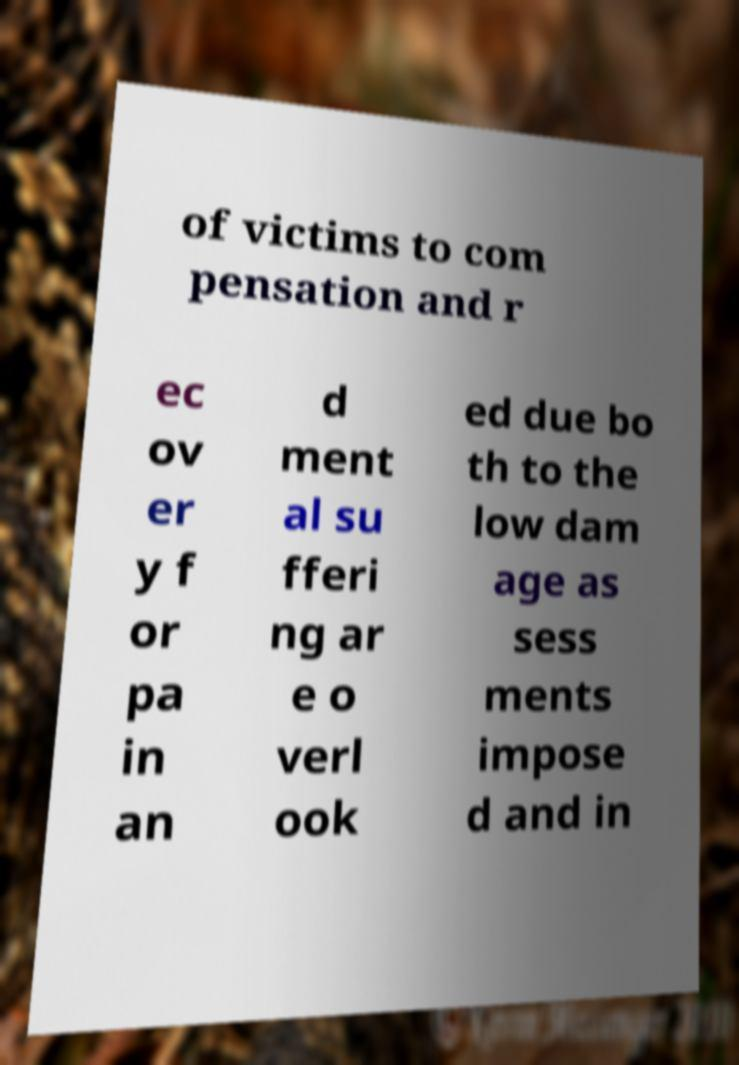Please identify and transcribe the text found in this image. of victims to com pensation and r ec ov er y f or pa in an d ment al su fferi ng ar e o verl ook ed due bo th to the low dam age as sess ments impose d and in 